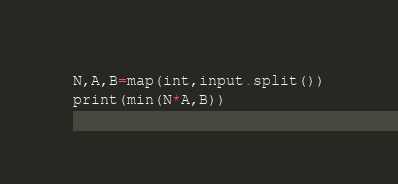<code> <loc_0><loc_0><loc_500><loc_500><_Python_>N,A,B=map(int,input.split())
print(min(N*A,B))</code> 